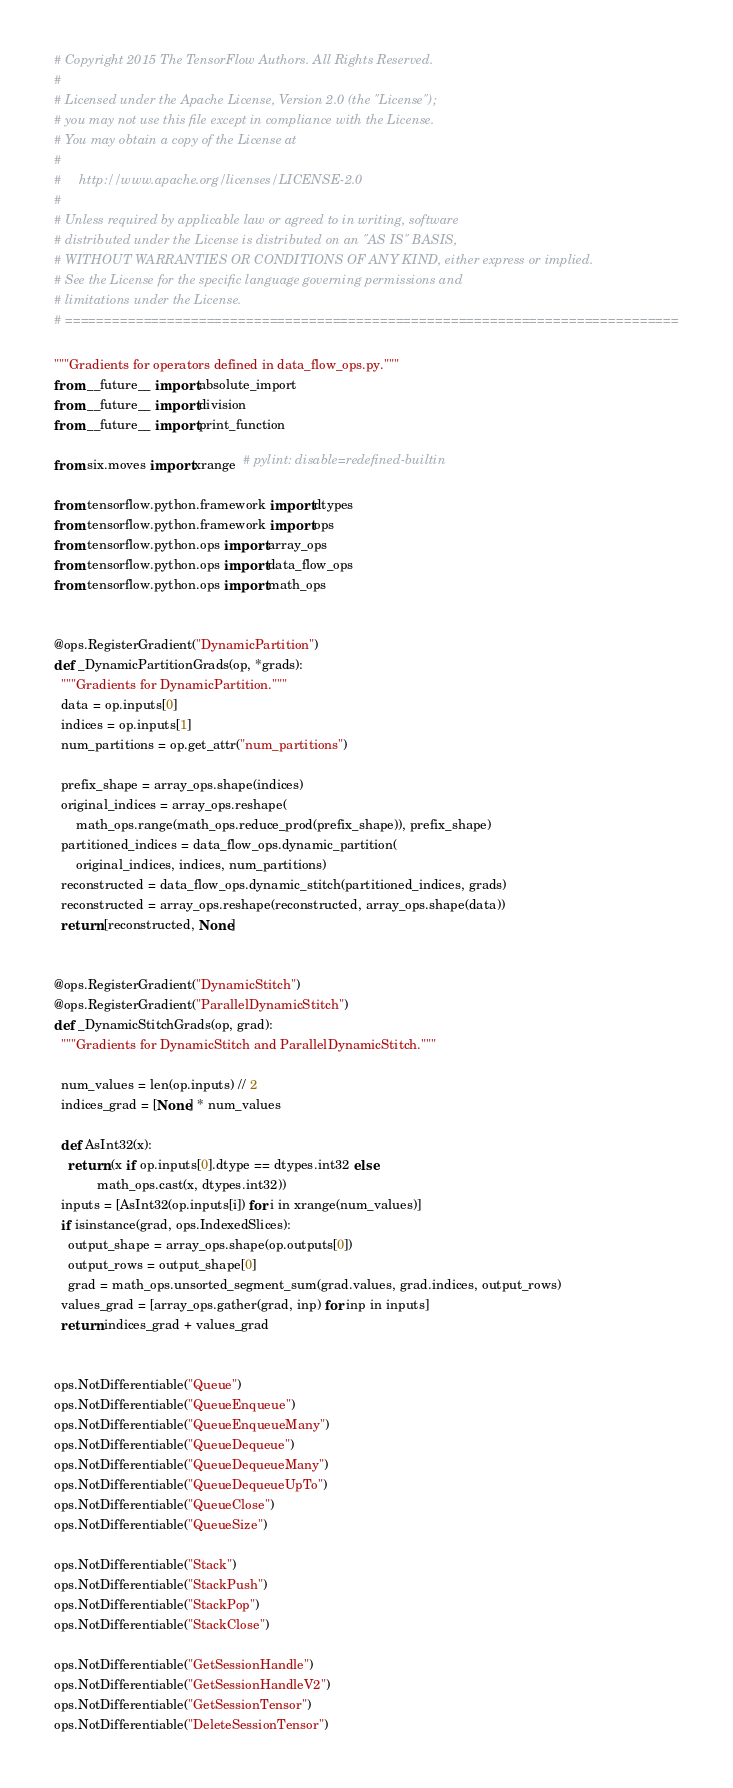Convert code to text. <code><loc_0><loc_0><loc_500><loc_500><_Python_># Copyright 2015 The TensorFlow Authors. All Rights Reserved.
#
# Licensed under the Apache License, Version 2.0 (the "License");
# you may not use this file except in compliance with the License.
# You may obtain a copy of the License at
#
#     http://www.apache.org/licenses/LICENSE-2.0
#
# Unless required by applicable law or agreed to in writing, software
# distributed under the License is distributed on an "AS IS" BASIS,
# WITHOUT WARRANTIES OR CONDITIONS OF ANY KIND, either express or implied.
# See the License for the specific language governing permissions and
# limitations under the License.
# ==============================================================================

"""Gradients for operators defined in data_flow_ops.py."""
from __future__ import absolute_import
from __future__ import division
from __future__ import print_function

from six.moves import xrange  # pylint: disable=redefined-builtin

from tensorflow.python.framework import dtypes
from tensorflow.python.framework import ops
from tensorflow.python.ops import array_ops
from tensorflow.python.ops import data_flow_ops
from tensorflow.python.ops import math_ops


@ops.RegisterGradient("DynamicPartition")
def _DynamicPartitionGrads(op, *grads):
  """Gradients for DynamicPartition."""
  data = op.inputs[0]
  indices = op.inputs[1]
  num_partitions = op.get_attr("num_partitions")

  prefix_shape = array_ops.shape(indices)
  original_indices = array_ops.reshape(
      math_ops.range(math_ops.reduce_prod(prefix_shape)), prefix_shape)
  partitioned_indices = data_flow_ops.dynamic_partition(
      original_indices, indices, num_partitions)
  reconstructed = data_flow_ops.dynamic_stitch(partitioned_indices, grads)
  reconstructed = array_ops.reshape(reconstructed, array_ops.shape(data))
  return [reconstructed, None]


@ops.RegisterGradient("DynamicStitch")
@ops.RegisterGradient("ParallelDynamicStitch")
def _DynamicStitchGrads(op, grad):
  """Gradients for DynamicStitch and ParallelDynamicStitch."""

  num_values = len(op.inputs) // 2
  indices_grad = [None] * num_values

  def AsInt32(x):
    return (x if op.inputs[0].dtype == dtypes.int32 else
            math_ops.cast(x, dtypes.int32))
  inputs = [AsInt32(op.inputs[i]) for i in xrange(num_values)]
  if isinstance(grad, ops.IndexedSlices):
    output_shape = array_ops.shape(op.outputs[0])
    output_rows = output_shape[0]
    grad = math_ops.unsorted_segment_sum(grad.values, grad.indices, output_rows)
  values_grad = [array_ops.gather(grad, inp) for inp in inputs]
  return indices_grad + values_grad


ops.NotDifferentiable("Queue")
ops.NotDifferentiable("QueueEnqueue")
ops.NotDifferentiable("QueueEnqueueMany")
ops.NotDifferentiable("QueueDequeue")
ops.NotDifferentiable("QueueDequeueMany")
ops.NotDifferentiable("QueueDequeueUpTo")
ops.NotDifferentiable("QueueClose")
ops.NotDifferentiable("QueueSize")

ops.NotDifferentiable("Stack")
ops.NotDifferentiable("StackPush")
ops.NotDifferentiable("StackPop")
ops.NotDifferentiable("StackClose")

ops.NotDifferentiable("GetSessionHandle")
ops.NotDifferentiable("GetSessionHandleV2")
ops.NotDifferentiable("GetSessionTensor")
ops.NotDifferentiable("DeleteSessionTensor")
</code> 